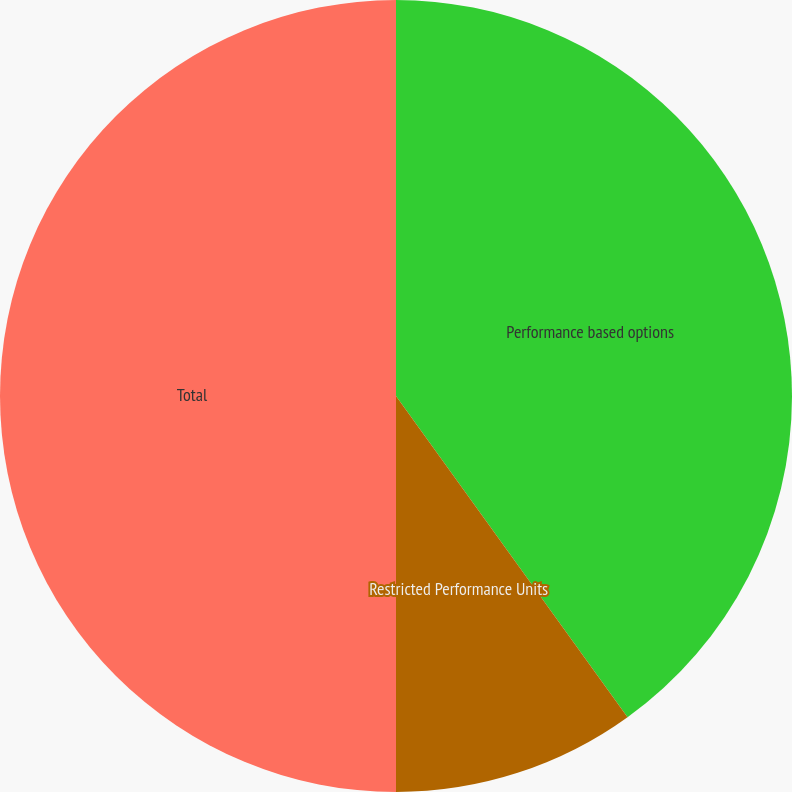<chart> <loc_0><loc_0><loc_500><loc_500><pie_chart><fcel>Performance based options<fcel>Restricted Performance Units<fcel>Total<nl><fcel>40.06%<fcel>9.94%<fcel>50.0%<nl></chart> 